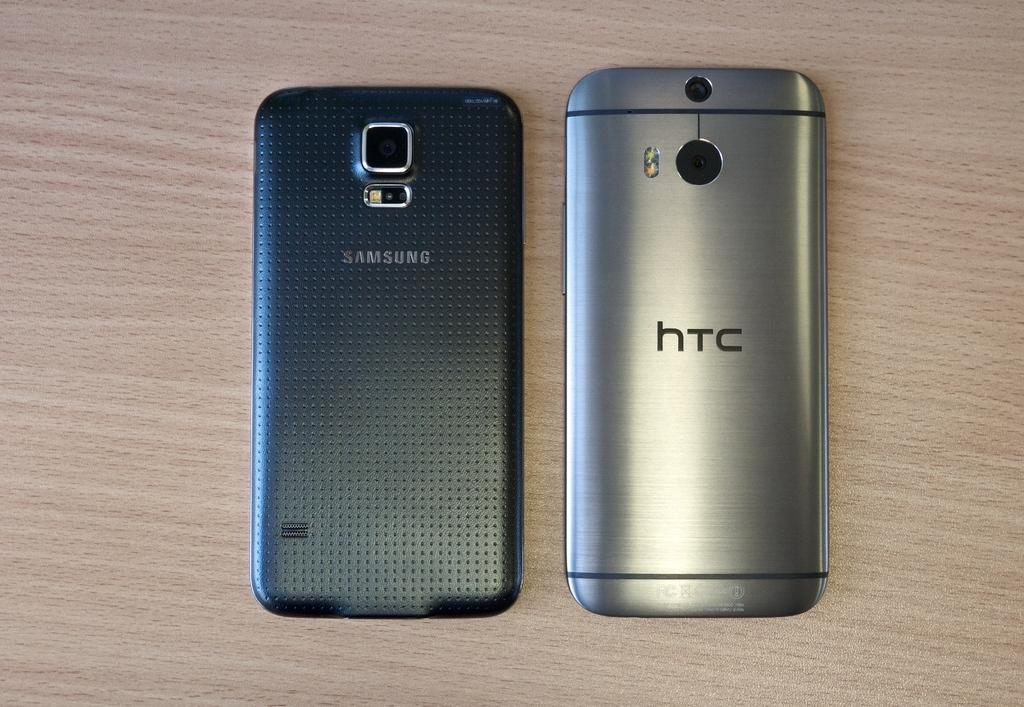<image>
Create a compact narrative representing the image presented. Samsung and HTC phones lay screen down on wooden surface. 